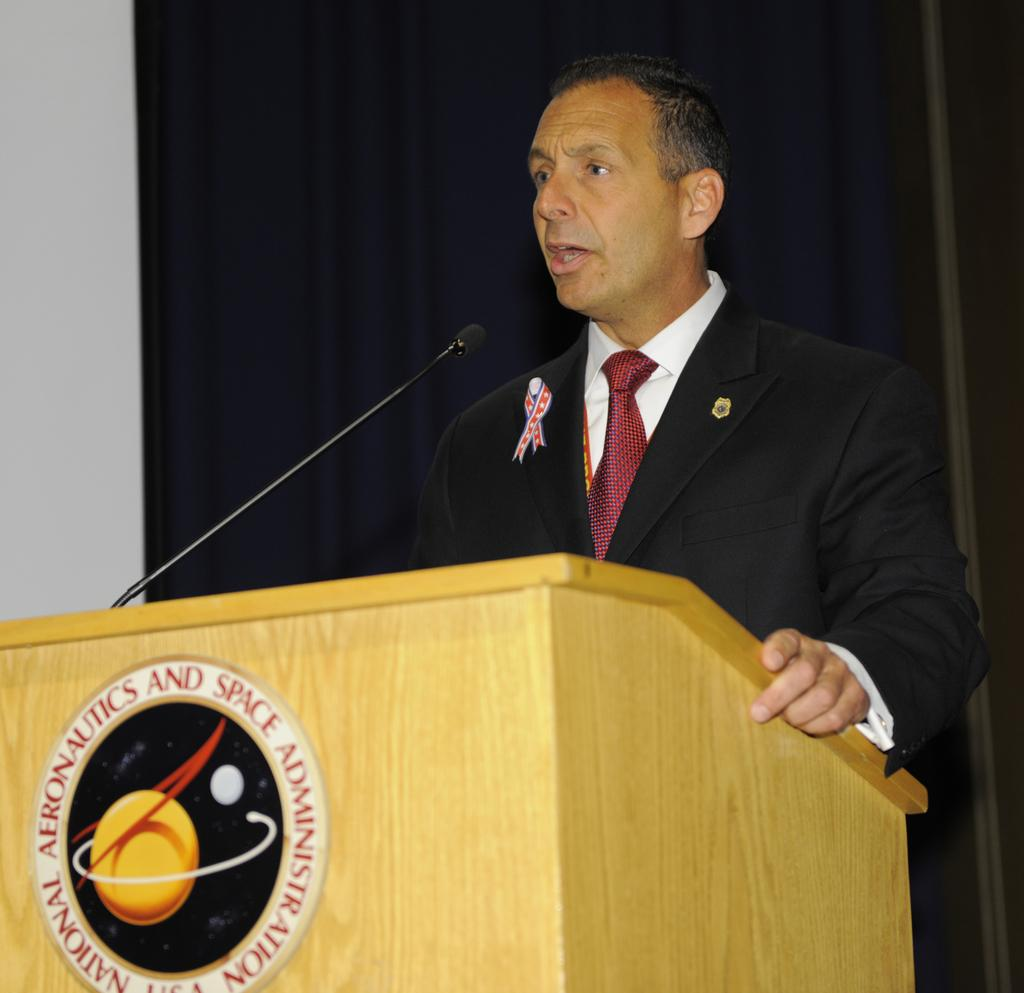What is the person in the image doing? The person is standing at the desk. What can be seen in the background of the image? There is a curtain and a wall in the background of the image. What type of cushion is the person sitting on in the image? There is no cushion present in the image, as the person is standing at the desk. What color is the sock the person is wearing in the image? There is no sock visible in the image, as the person is standing at the desk and wearing pants or a long skirt. 